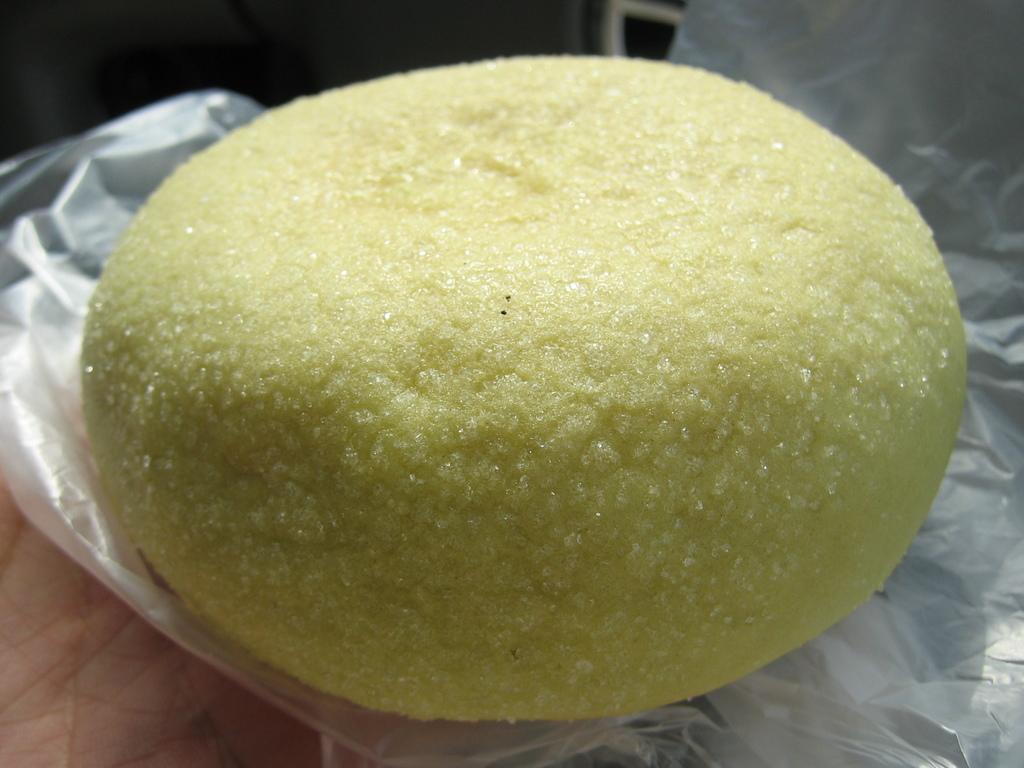In one or two sentences, can you explain what this image depicts? In this image a person's having is visible. He is holding a cover which is having some food on it. Background is blurry. 